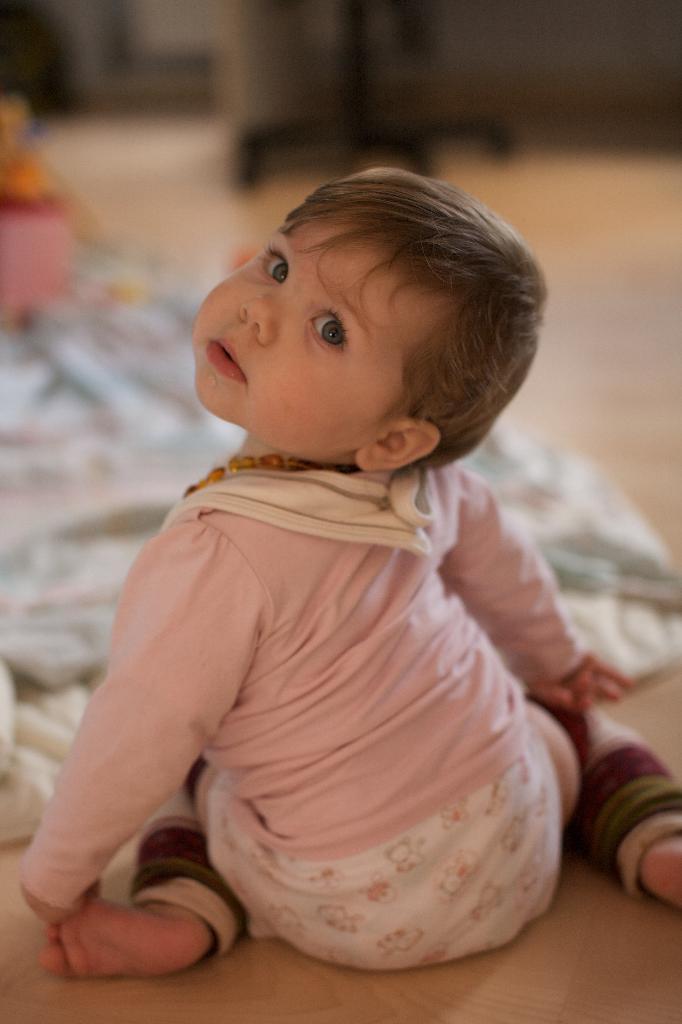Could you give a brief overview of what you see in this image? In front of the image there is a boy sitting on the floor. In front of him there is a blanket and there are some other objects. 